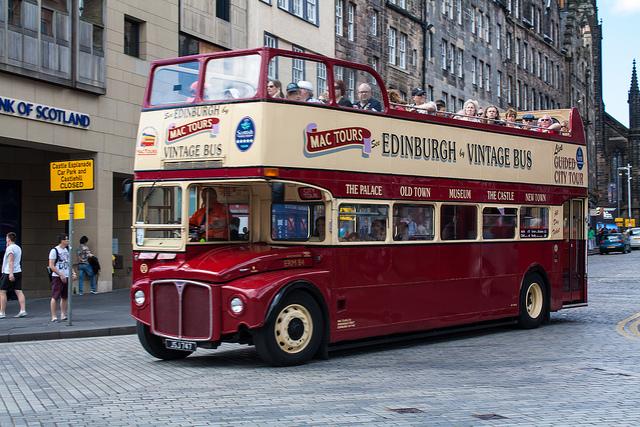What is the woman's name on the bus?
Write a very short answer. Mac. What city is this in?
Be succinct. Edinburgh. Is anyone in the bus?
Write a very short answer. Yes. What city is this?
Give a very brief answer. Edinburgh. What country are they in?
Give a very brief answer. Scotland. Are the buses for private or public transportation?
Keep it brief. Private. What color is the bus?
Give a very brief answer. Red. What area is this bus for?
Keep it brief. Edinburgh. What color is the man farthest left's shirt?
Give a very brief answer. White. Is the bus full of people?
Quick response, please. Yes. IS the bus in motion?
Short answer required. Yes. Where is this tour bus?
Give a very brief answer. Edinburgh. What fantasy movie has a magic bus similar to this one?
Give a very brief answer. Harry potter. Is there anyone in the bus?
Be succinct. Yes. 